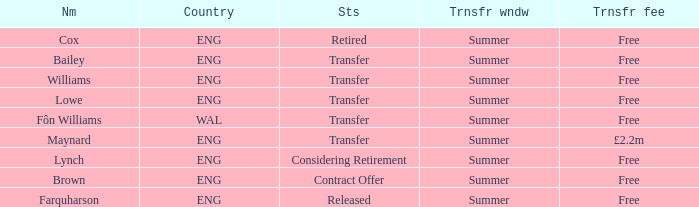What is the status of the ENG Country with the name of Farquharson? Released. 